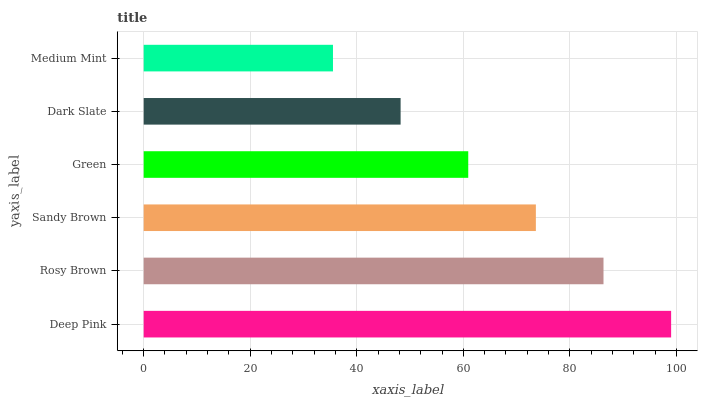Is Medium Mint the minimum?
Answer yes or no. Yes. Is Deep Pink the maximum?
Answer yes or no. Yes. Is Rosy Brown the minimum?
Answer yes or no. No. Is Rosy Brown the maximum?
Answer yes or no. No. Is Deep Pink greater than Rosy Brown?
Answer yes or no. Yes. Is Rosy Brown less than Deep Pink?
Answer yes or no. Yes. Is Rosy Brown greater than Deep Pink?
Answer yes or no. No. Is Deep Pink less than Rosy Brown?
Answer yes or no. No. Is Sandy Brown the high median?
Answer yes or no. Yes. Is Green the low median?
Answer yes or no. Yes. Is Rosy Brown the high median?
Answer yes or no. No. Is Deep Pink the low median?
Answer yes or no. No. 